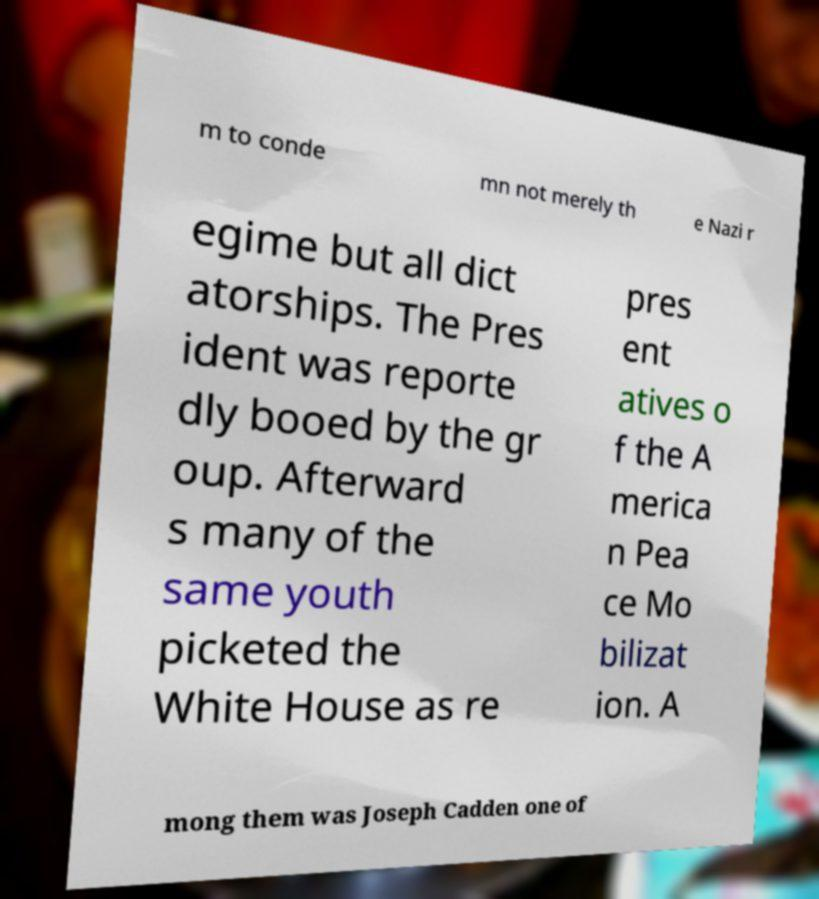Could you assist in decoding the text presented in this image and type it out clearly? m to conde mn not merely th e Nazi r egime but all dict atorships. The Pres ident was reporte dly booed by the gr oup. Afterward s many of the same youth picketed the White House as re pres ent atives o f the A merica n Pea ce Mo bilizat ion. A mong them was Joseph Cadden one of 